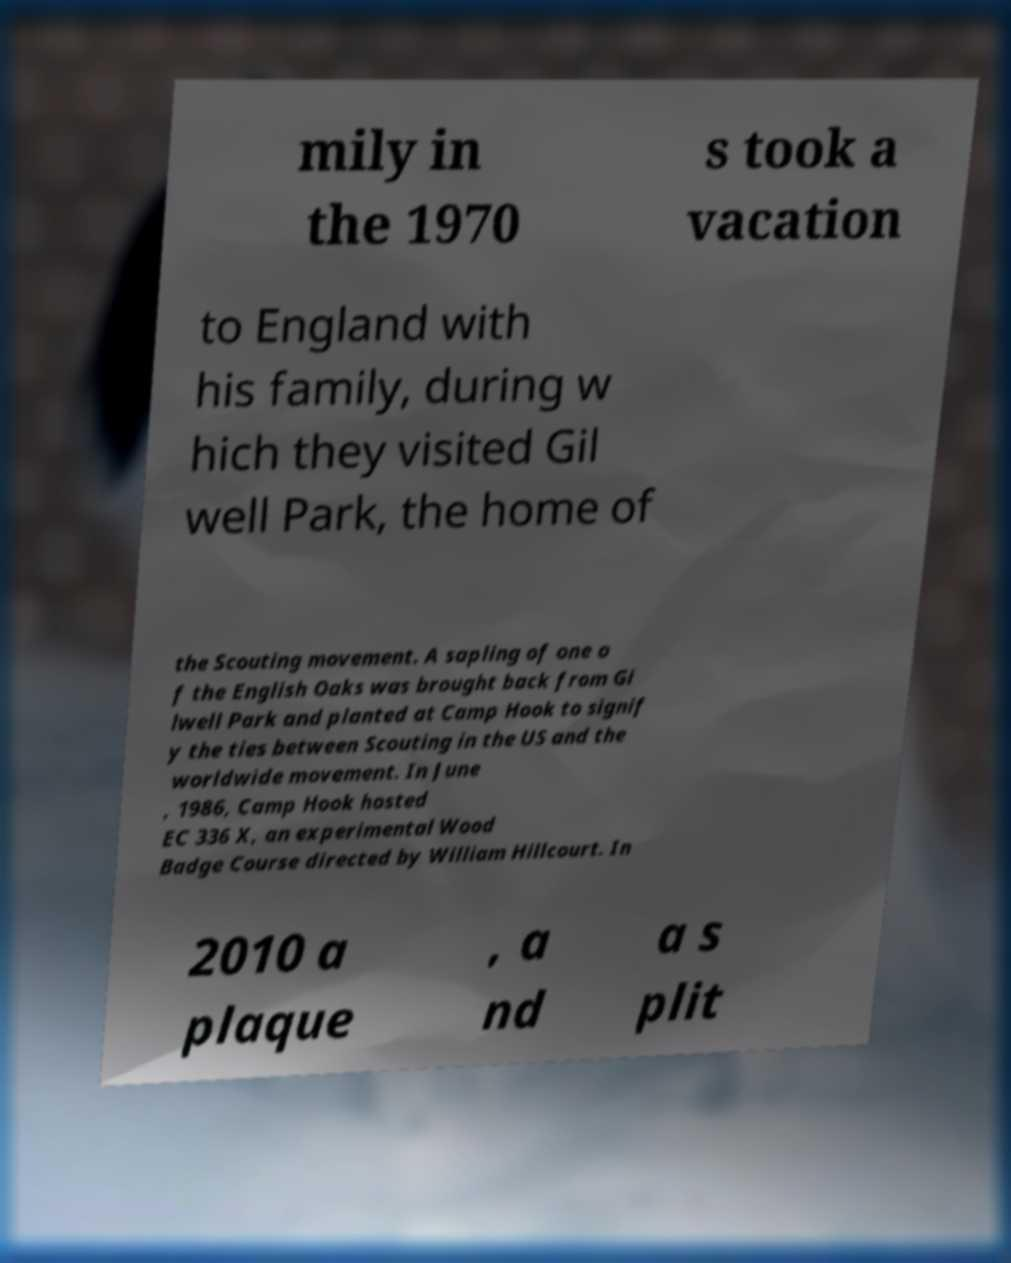Could you assist in decoding the text presented in this image and type it out clearly? mily in the 1970 s took a vacation to England with his family, during w hich they visited Gil well Park, the home of the Scouting movement. A sapling of one o f the English Oaks was brought back from Gi lwell Park and planted at Camp Hook to signif y the ties between Scouting in the US and the worldwide movement. In June , 1986, Camp Hook hosted EC 336 X, an experimental Wood Badge Course directed by William Hillcourt. In 2010 a plaque , a nd a s plit 